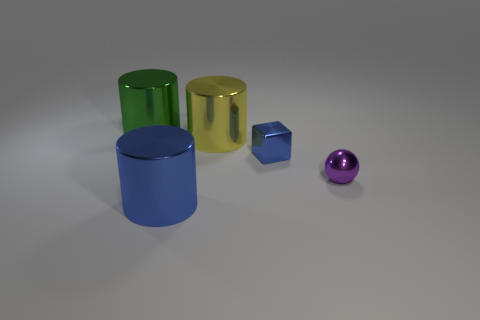Add 1 tiny blue shiny objects. How many objects exist? 6 Subtract all cubes. How many objects are left? 4 Add 4 tiny brown balls. How many tiny brown balls exist? 4 Subtract 0 yellow blocks. How many objects are left? 5 Subtract all tiny spheres. Subtract all yellow objects. How many objects are left? 3 Add 1 metallic balls. How many metallic balls are left? 2 